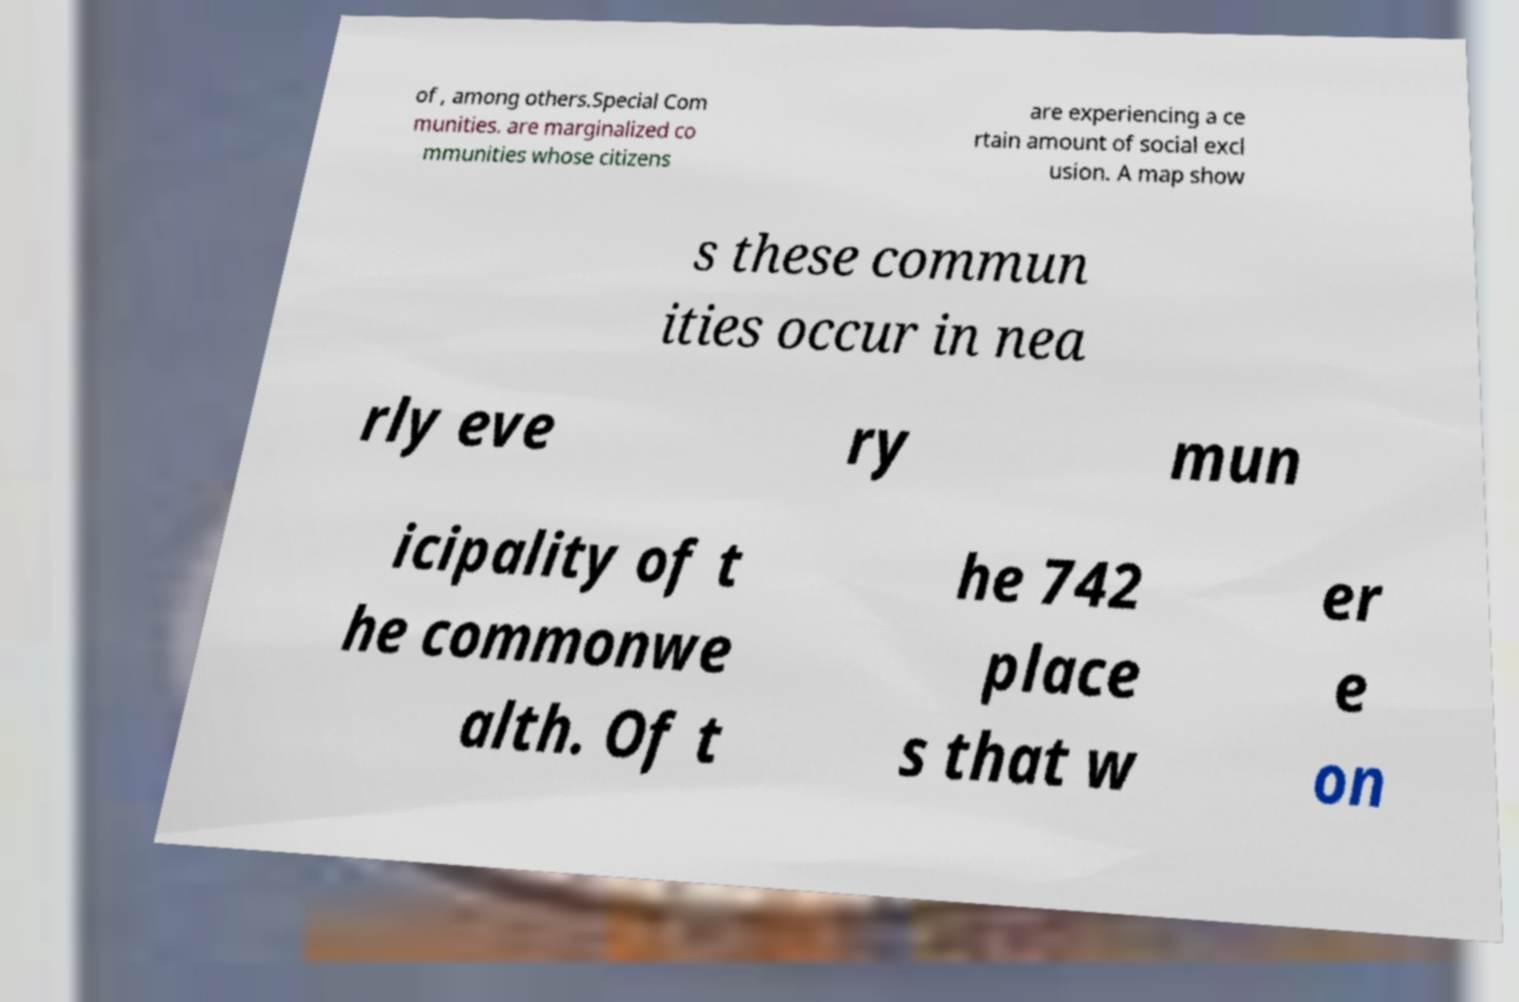Could you extract and type out the text from this image? of , among others.Special Com munities. are marginalized co mmunities whose citizens are experiencing a ce rtain amount of social excl usion. A map show s these commun ities occur in nea rly eve ry mun icipality of t he commonwe alth. Of t he 742 place s that w er e on 